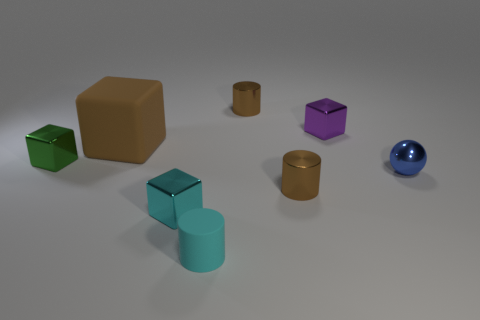What is the material of the cube that is the same color as the tiny matte cylinder?
Offer a very short reply. Metal. The brown matte thing has what shape?
Provide a succinct answer. Cube. There is a cyan rubber object that is the same size as the green object; what shape is it?
Ensure brevity in your answer.  Cylinder. How many other things are there of the same color as the ball?
Your answer should be very brief. 0. There is a tiny brown thing that is behind the big block; is it the same shape as the brown object in front of the brown matte thing?
Provide a short and direct response. Yes. How many things are either tiny blocks behind the ball or metallic objects that are right of the purple metallic block?
Keep it short and to the point. 3. How many other things are the same material as the green cube?
Keep it short and to the point. 5. Does the thing in front of the small cyan metal thing have the same material as the blue object?
Keep it short and to the point. No. Are there more small shiny blocks that are behind the green shiny cube than blue shiny objects that are behind the small blue object?
Your answer should be very brief. Yes. What number of things are either metallic cylinders that are behind the brown cube or shiny things?
Ensure brevity in your answer.  6. 